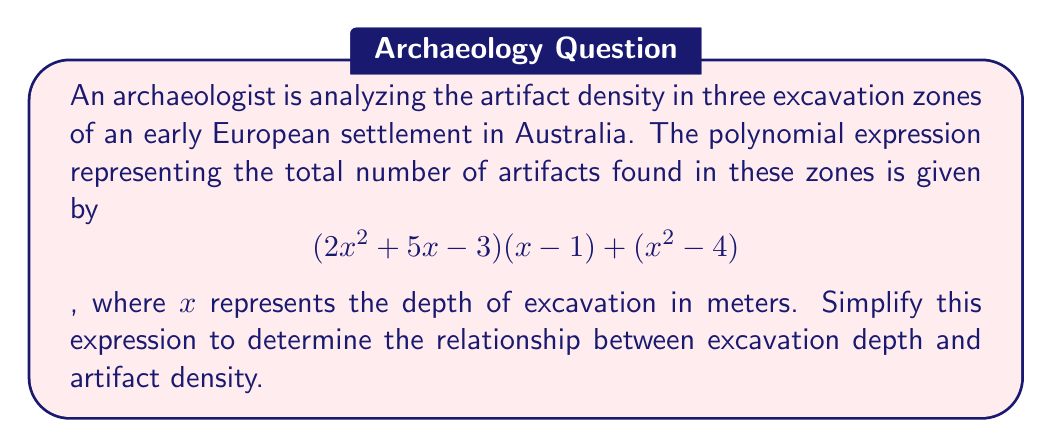Give your solution to this math problem. Let's simplify the polynomial expression step by step:

1) First, let's expand $(2x^2 + 5x - 3)(x - 1)$:
   $$(2x^2 + 5x - 3)(x - 1) = 2x^3 - 2x^2 + 5x^2 - 5x - 3x + 3$$
   $$= 2x^3 + 3x^2 - 8x + 3$$

2) Now, we have:
   $$(2x^3 + 3x^2 - 8x + 3) + (x^2 - 4)$$

3) Let's combine like terms:
   $$2x^3 + (3x^2 + x^2) + (-8x) + (3 - 4)$$
   $$= 2x^3 + 4x^2 - 8x - 1$$

4) This simplified polynomial represents the relationship between excavation depth $(x)$ and the total number of artifacts.

5) The coefficient of $x^3$ (2) indicates that the artifact density increases rapidly with depth.
   The coefficient of $x^2$ (4) suggests a moderate increase in density in middle depths.
   The negative coefficient of $x$ (-8) implies a slight decrease in density at shallower depths.
   The constant term (-1) adjusts the overall count.
Answer: $$2x^3 + 4x^2 - 8x - 1$$ 